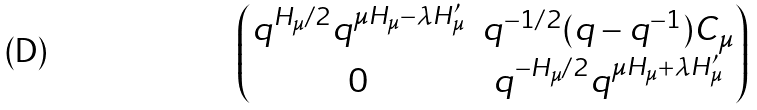<formula> <loc_0><loc_0><loc_500><loc_500>\begin{pmatrix} q ^ { H _ { \mu } / 2 } q ^ { \mu H _ { \mu } - \lambda H ^ { \prime } _ { \mu } } & q ^ { - 1 / 2 } ( q - q ^ { - 1 } ) C _ { \mu } \\ 0 & q ^ { - H _ { \mu } / 2 } q ^ { \mu H _ { \mu } + \lambda H ^ { \prime } _ { \mu } } \end{pmatrix}</formula> 